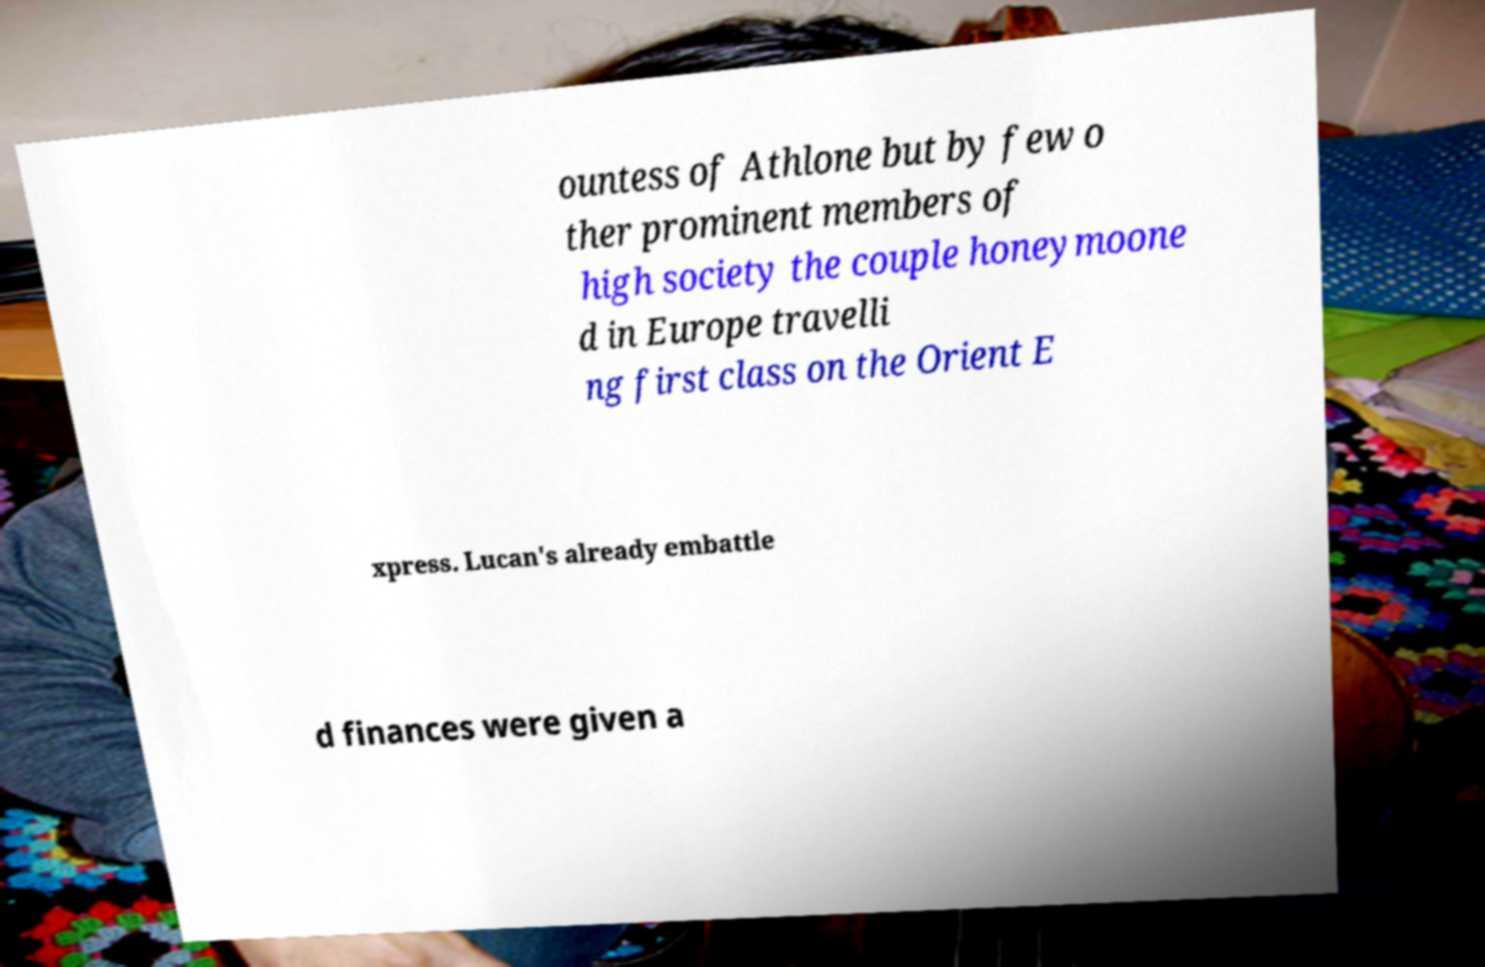Can you read and provide the text displayed in the image?This photo seems to have some interesting text. Can you extract and type it out for me? ountess of Athlone but by few o ther prominent members of high society the couple honeymoone d in Europe travelli ng first class on the Orient E xpress. Lucan's already embattle d finances were given a 